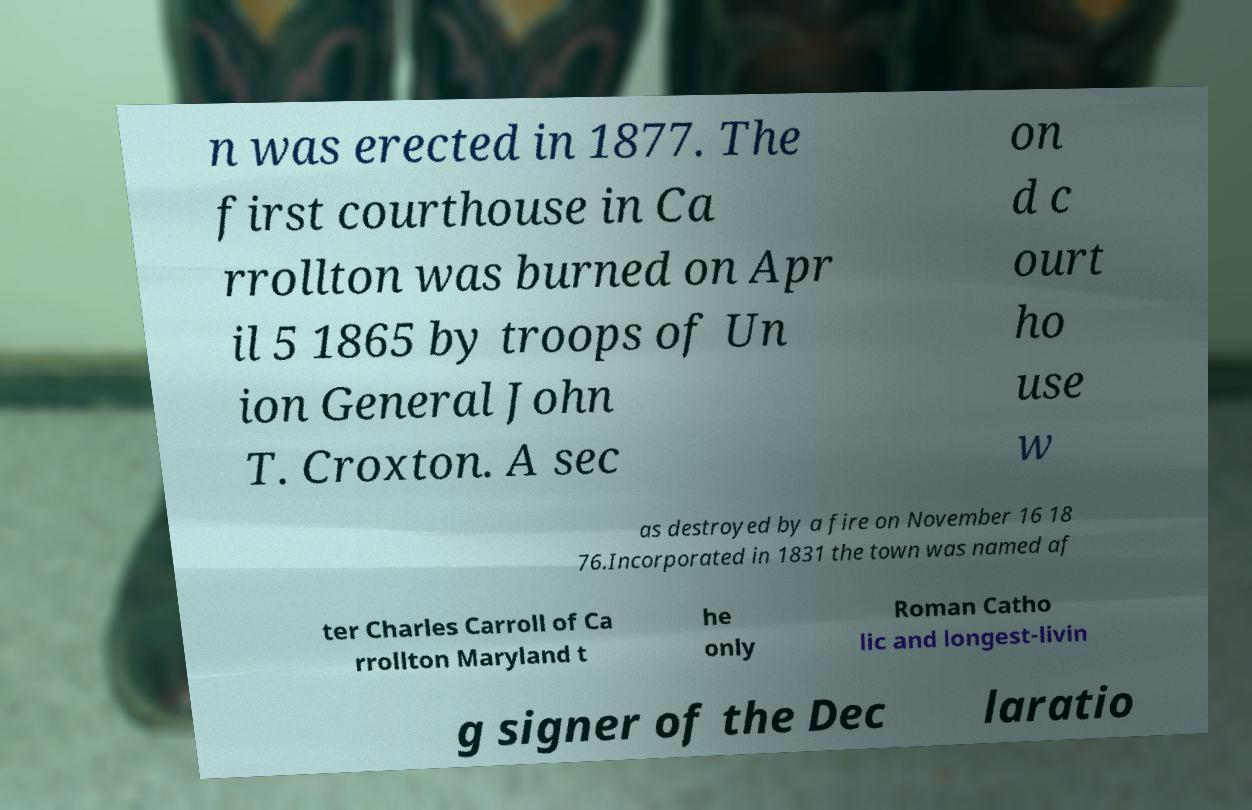I need the written content from this picture converted into text. Can you do that? n was erected in 1877. The first courthouse in Ca rrollton was burned on Apr il 5 1865 by troops of Un ion General John T. Croxton. A sec on d c ourt ho use w as destroyed by a fire on November 16 18 76.Incorporated in 1831 the town was named af ter Charles Carroll of Ca rrollton Maryland t he only Roman Catho lic and longest-livin g signer of the Dec laratio 